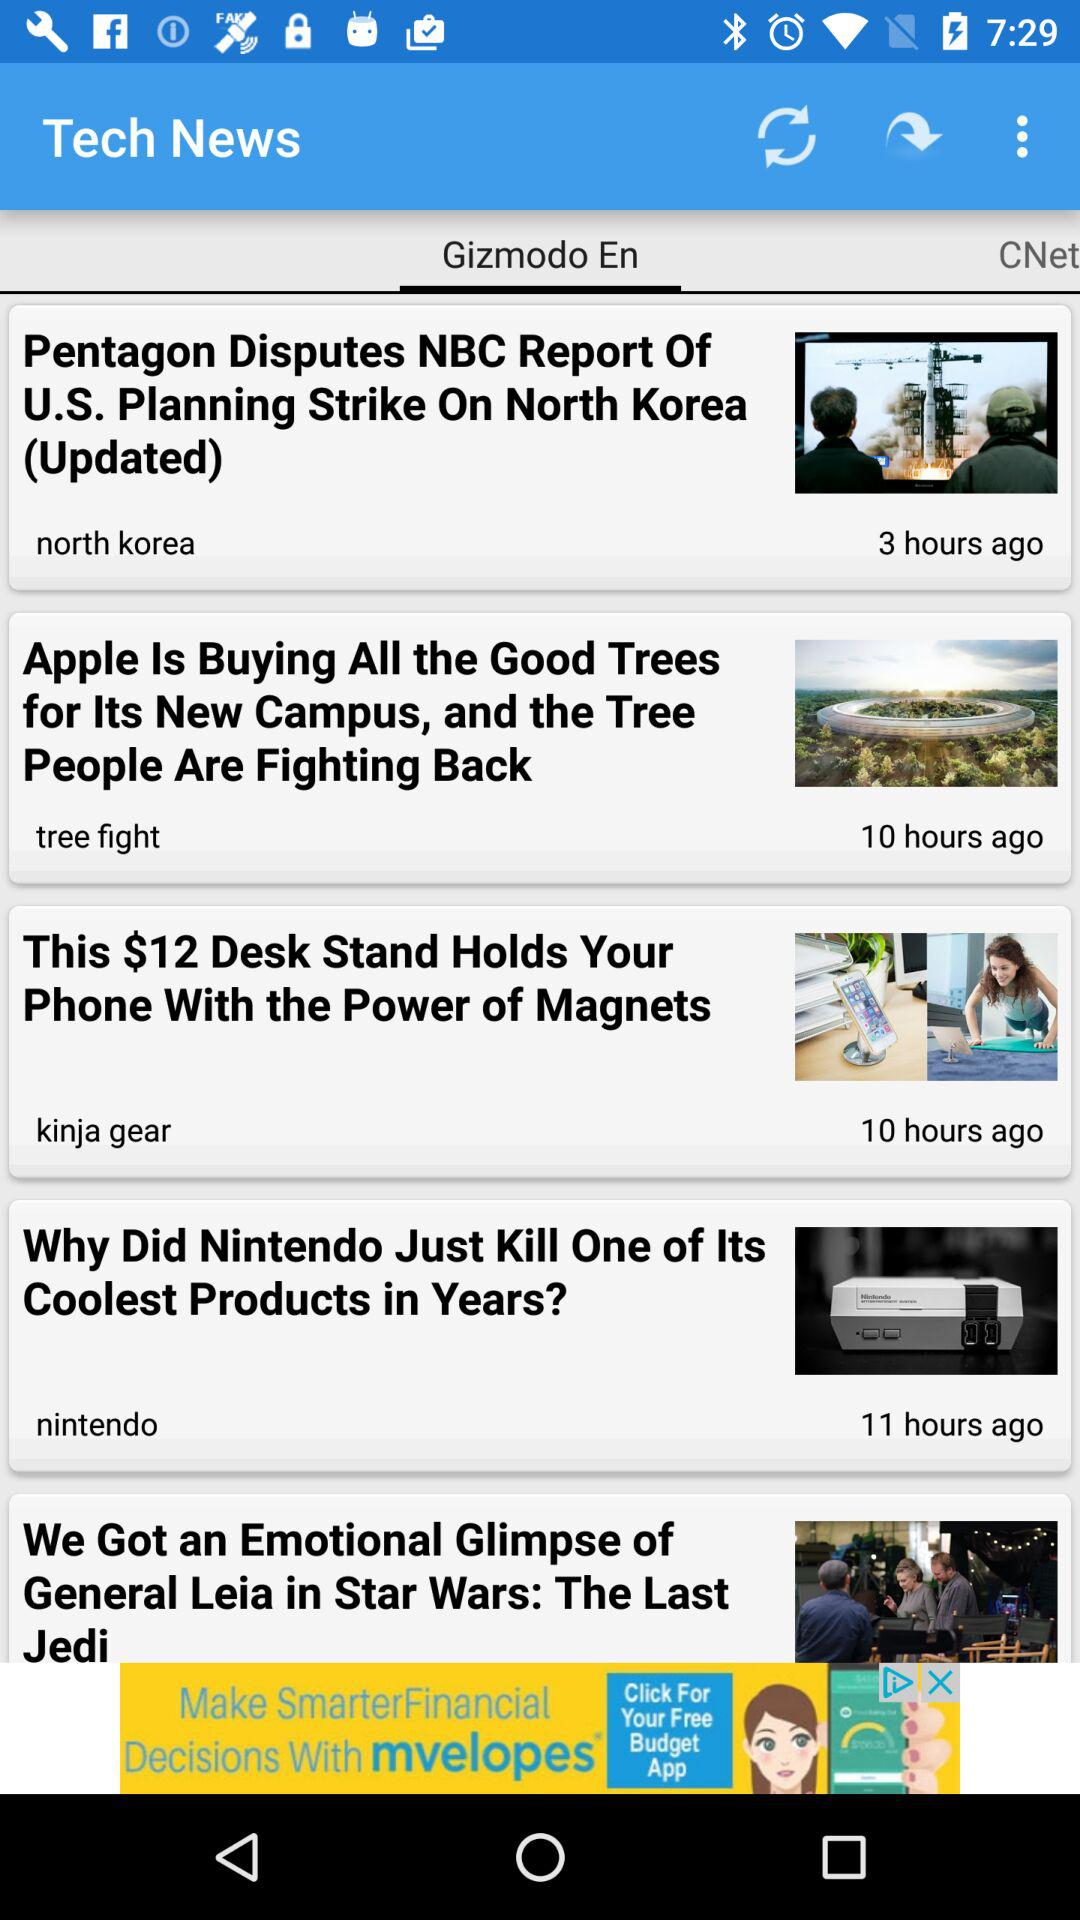How many hours ago was the news about the trees posted? The news about the trees was posted 10 hours ago. 